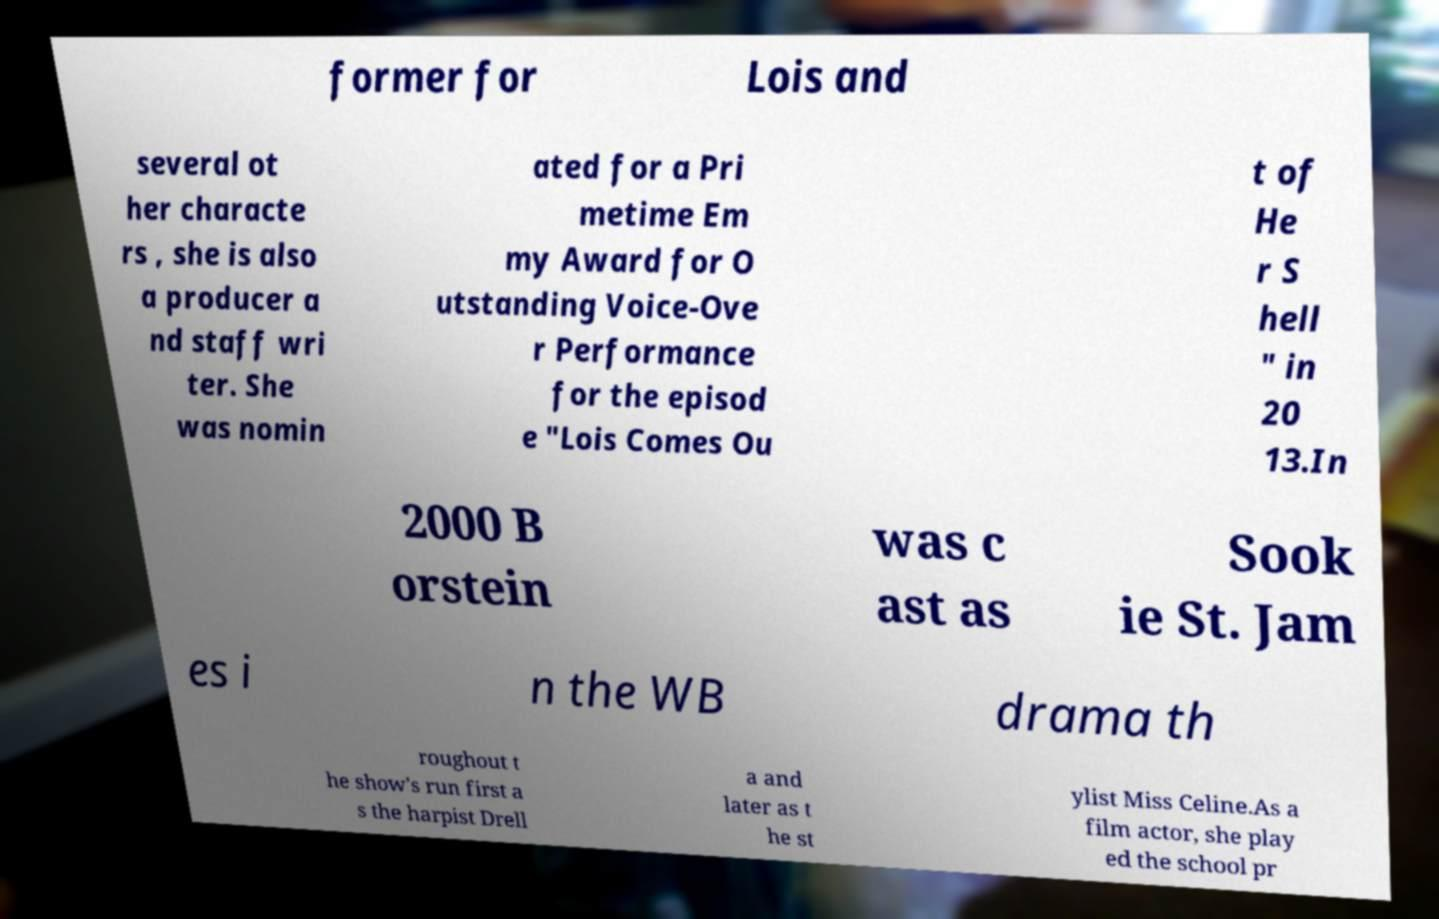Could you extract and type out the text from this image? former for Lois and several ot her characte rs , she is also a producer a nd staff wri ter. She was nomin ated for a Pri metime Em my Award for O utstanding Voice-Ove r Performance for the episod e "Lois Comes Ou t of He r S hell " in 20 13.In 2000 B orstein was c ast as Sook ie St. Jam es i n the WB drama th roughout t he show's run first a s the harpist Drell a and later as t he st ylist Miss Celine.As a film actor, she play ed the school pr 